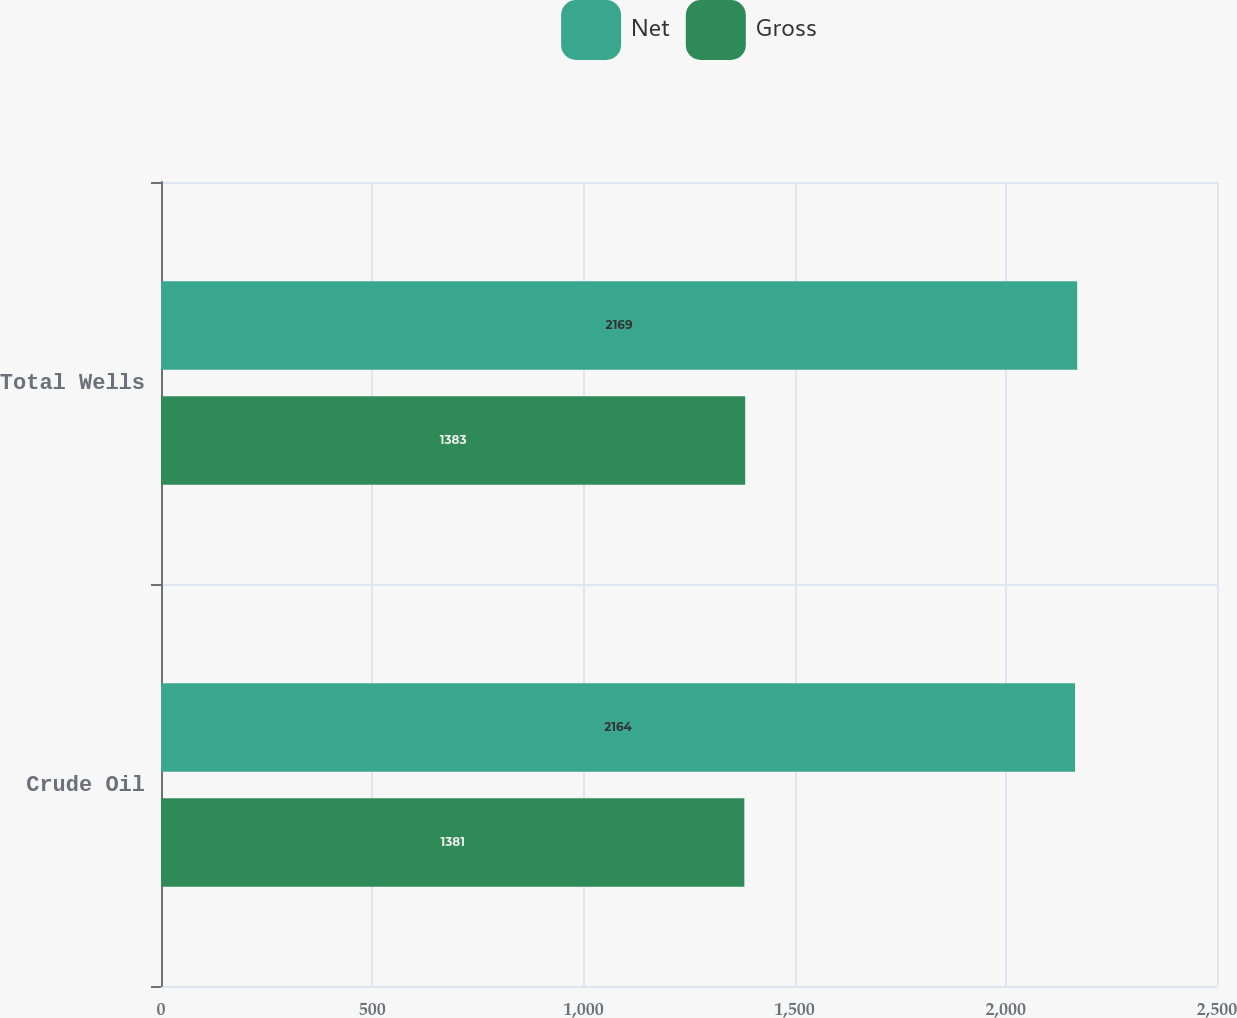Convert chart. <chart><loc_0><loc_0><loc_500><loc_500><stacked_bar_chart><ecel><fcel>Crude Oil<fcel>Total Wells<nl><fcel>Net<fcel>2164<fcel>2169<nl><fcel>Gross<fcel>1381<fcel>1383<nl></chart> 